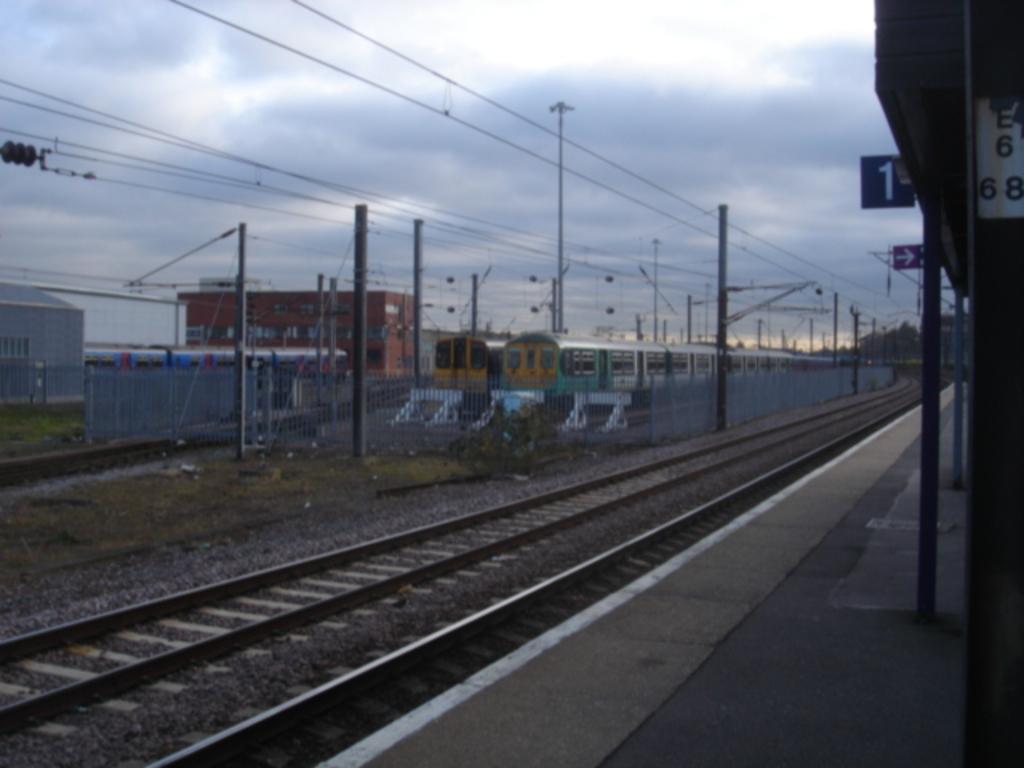Describe this image in one or two sentences. In this picture there is a view of the railway station. In the front there is a railway track and two trains are parked. In the background we can see a brown color building and some electric poles and cables. On the right side there is a railway shed with blue color boards. 